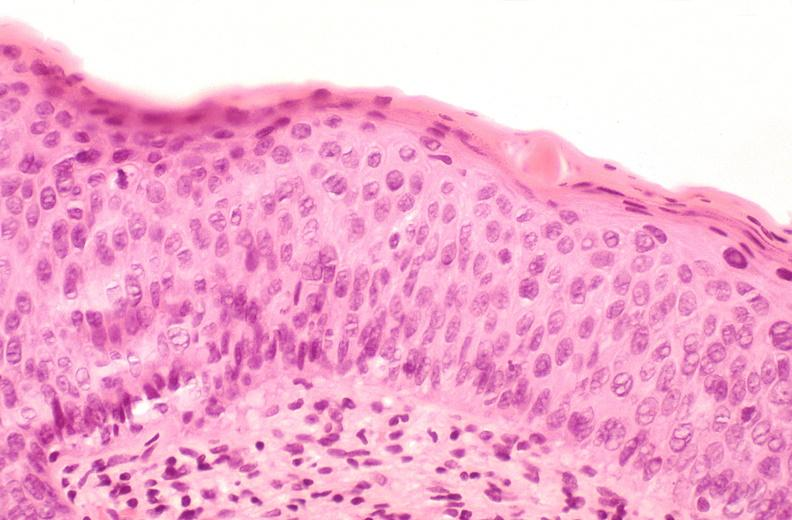does liver show cervix, moderate to severe dysplasia?
Answer the question using a single word or phrase. No 